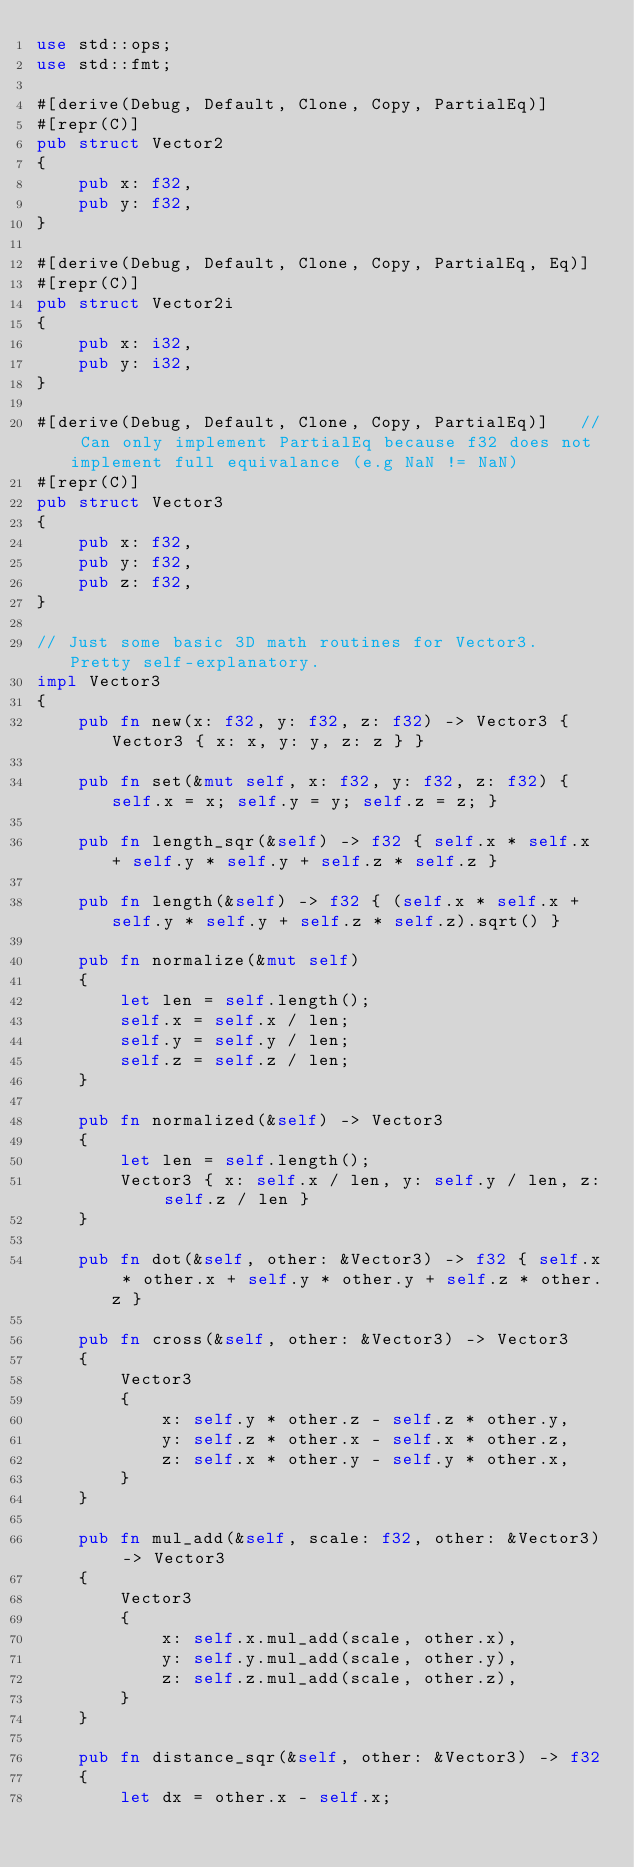Convert code to text. <code><loc_0><loc_0><loc_500><loc_500><_Rust_>use std::ops;
use std::fmt;

#[derive(Debug, Default, Clone, Copy, PartialEq)]
#[repr(C)]
pub struct Vector2
{
    pub x: f32,
    pub y: f32,
}

#[derive(Debug, Default, Clone, Copy, PartialEq, Eq)]
#[repr(C)]
pub struct Vector2i
{
    pub x: i32,
    pub y: i32,
}

#[derive(Debug, Default, Clone, Copy, PartialEq)]   // Can only implement PartialEq because f32 does not implement full equivalance (e.g NaN != NaN)
#[repr(C)]
pub struct Vector3
{
    pub x: f32,
    pub y: f32,
    pub z: f32,
}

// Just some basic 3D math routines for Vector3. Pretty self-explanatory.
impl Vector3
{
    pub fn new(x: f32, y: f32, z: f32) -> Vector3 { Vector3 { x: x, y: y, z: z } }

    pub fn set(&mut self, x: f32, y: f32, z: f32) { self.x = x; self.y = y; self.z = z; }

    pub fn length_sqr(&self) -> f32 { self.x * self.x + self.y * self.y + self.z * self.z }

    pub fn length(&self) -> f32 { (self.x * self.x + self.y * self.y + self.z * self.z).sqrt() }

    pub fn normalize(&mut self)
    {
        let len = self.length();
        self.x = self.x / len;
        self.y = self.y / len;
        self.z = self.z / len;
    }

    pub fn normalized(&self) -> Vector3
    {
        let len = self.length();
        Vector3 { x: self.x / len, y: self.y / len, z: self.z / len }
    }

    pub fn dot(&self, other: &Vector3) -> f32 { self.x * other.x + self.y * other.y + self.z * other.z }

    pub fn cross(&self, other: &Vector3) -> Vector3
    {
        Vector3
        {
            x: self.y * other.z - self.z * other.y,
            y: self.z * other.x - self.x * other.z,
            z: self.x * other.y - self.y * other.x,
        }
    }

    pub fn mul_add(&self, scale: f32, other: &Vector3) -> Vector3
    {
        Vector3 
        {
            x: self.x.mul_add(scale, other.x),
            y: self.y.mul_add(scale, other.y),
            z: self.z.mul_add(scale, other.z),
        }
    }

    pub fn distance_sqr(&self, other: &Vector3) -> f32
    {
        let dx = other.x - self.x;</code> 